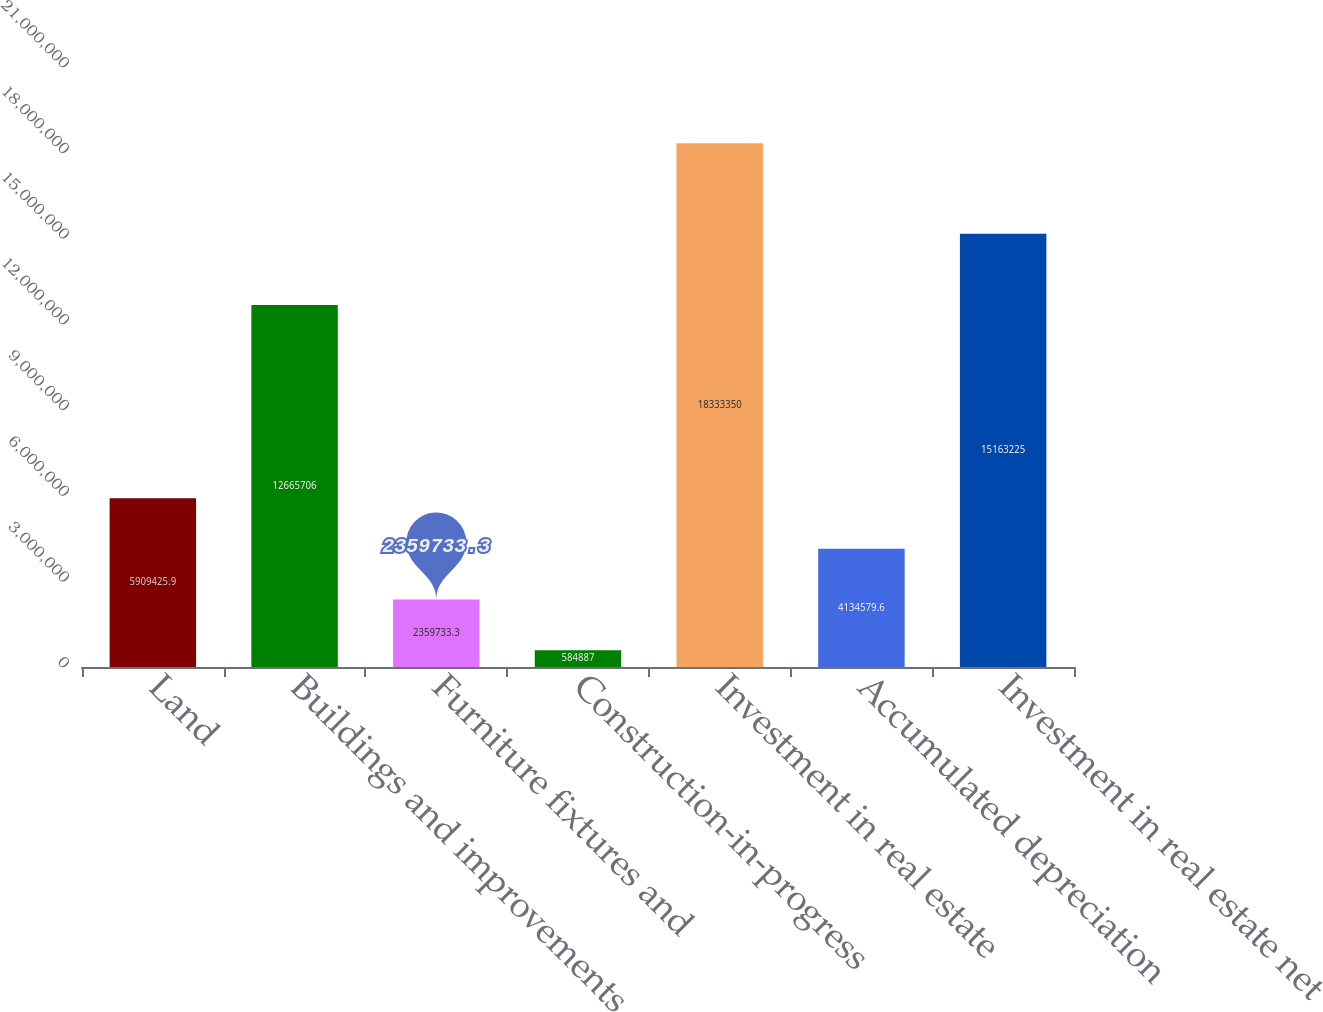Convert chart to OTSL. <chart><loc_0><loc_0><loc_500><loc_500><bar_chart><fcel>Land<fcel>Buildings and improvements<fcel>Furniture fixtures and<fcel>Construction-in-progress<fcel>Investment in real estate<fcel>Accumulated depreciation<fcel>Investment in real estate net<nl><fcel>5.90943e+06<fcel>1.26657e+07<fcel>2.35973e+06<fcel>584887<fcel>1.83334e+07<fcel>4.13458e+06<fcel>1.51632e+07<nl></chart> 